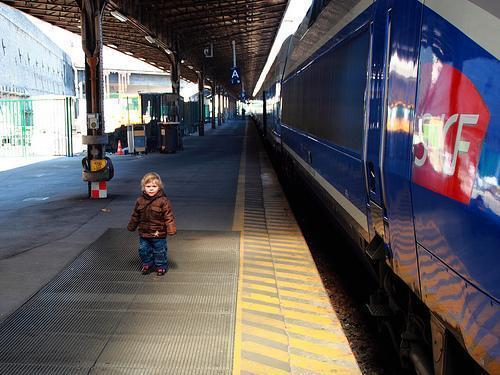How many people are in the picture?
Give a very brief answer. 1. 